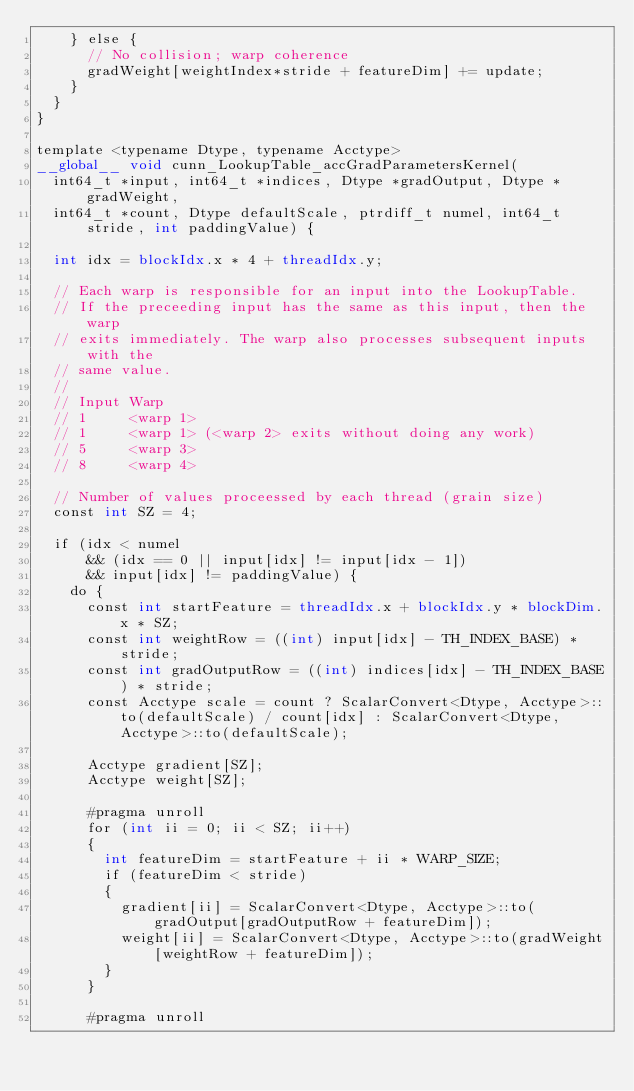Convert code to text. <code><loc_0><loc_0><loc_500><loc_500><_Cuda_>    } else {
      // No collision; warp coherence
      gradWeight[weightIndex*stride + featureDim] += update;
    }
  }
}

template <typename Dtype, typename Acctype>
__global__ void cunn_LookupTable_accGradParametersKernel(
  int64_t *input, int64_t *indices, Dtype *gradOutput, Dtype *gradWeight,
  int64_t *count, Dtype defaultScale, ptrdiff_t numel, int64_t stride, int paddingValue) {

  int idx = blockIdx.x * 4 + threadIdx.y;

  // Each warp is responsible for an input into the LookupTable.
  // If the preceeding input has the same as this input, then the warp
  // exits immediately. The warp also processes subsequent inputs with the
  // same value.
  //
  // Input Warp
  // 1     <warp 1>
  // 1     <warp 1> (<warp 2> exits without doing any work)
  // 5     <warp 3>
  // 8     <warp 4>

  // Number of values proceessed by each thread (grain size)
  const int SZ = 4;

  if (idx < numel
      && (idx == 0 || input[idx] != input[idx - 1])
      && input[idx] != paddingValue) {
    do {
      const int startFeature = threadIdx.x + blockIdx.y * blockDim.x * SZ;
      const int weightRow = ((int) input[idx] - TH_INDEX_BASE) * stride;
      const int gradOutputRow = ((int) indices[idx] - TH_INDEX_BASE) * stride;
      const Acctype scale = count ? ScalarConvert<Dtype, Acctype>::to(defaultScale) / count[idx] : ScalarConvert<Dtype, Acctype>::to(defaultScale);

      Acctype gradient[SZ];
      Acctype weight[SZ];

      #pragma unroll
      for (int ii = 0; ii < SZ; ii++)
      {
        int featureDim = startFeature + ii * WARP_SIZE;
        if (featureDim < stride)
        {
          gradient[ii] = ScalarConvert<Dtype, Acctype>::to(gradOutput[gradOutputRow + featureDim]);
          weight[ii] = ScalarConvert<Dtype, Acctype>::to(gradWeight[weightRow + featureDim]);
        }
      }

      #pragma unroll</code> 